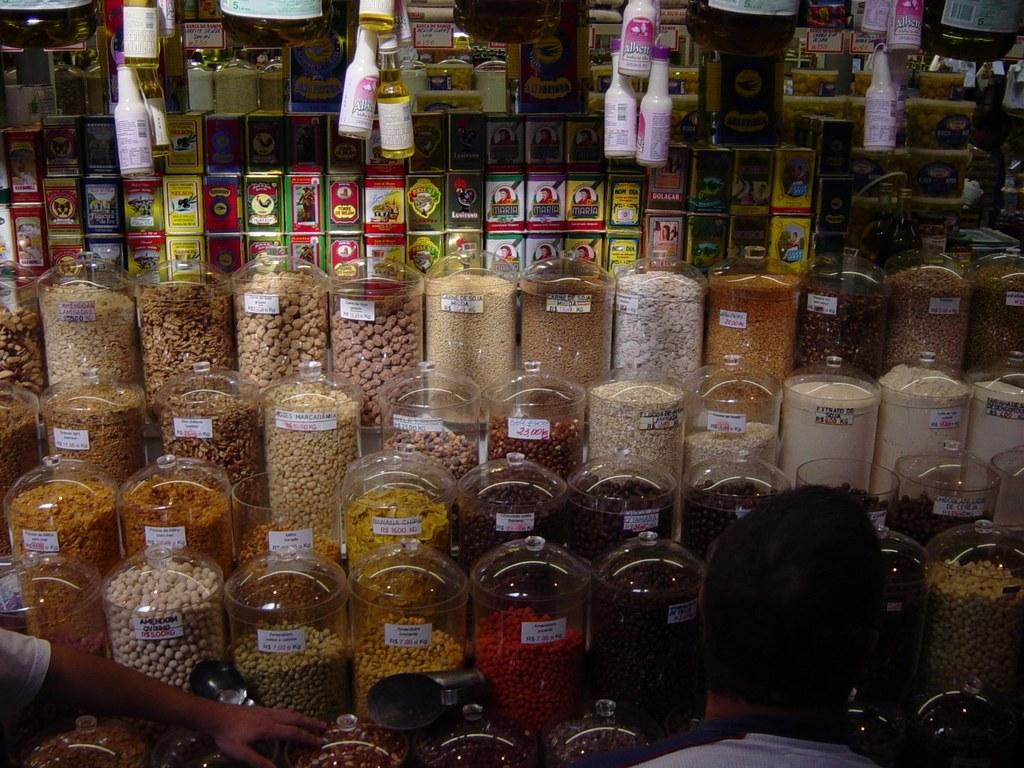How many people are in the image? There are two persons in the image. What can be seen behind the people? There is a group of jars containing different types of food items and a group of bottles visible behind the jars. What type of cord is being used to hold the rice in the image? There is no rice or cord present in the image. Can you tell me how many dogs are visible in the image? There are no dogs present in the image. 